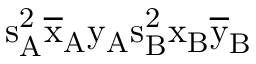Convert formula to latex. <formula><loc_0><loc_0><loc_500><loc_500>s _ { A } ^ { 2 } \mathrm { \overline { x } _ { A } \mathrm { y _ { A } \mathrm { s _ { B } ^ { 2 } \mathrm { x _ { B } \mathrm { \overline { y } _ { B } } } } } }</formula> 